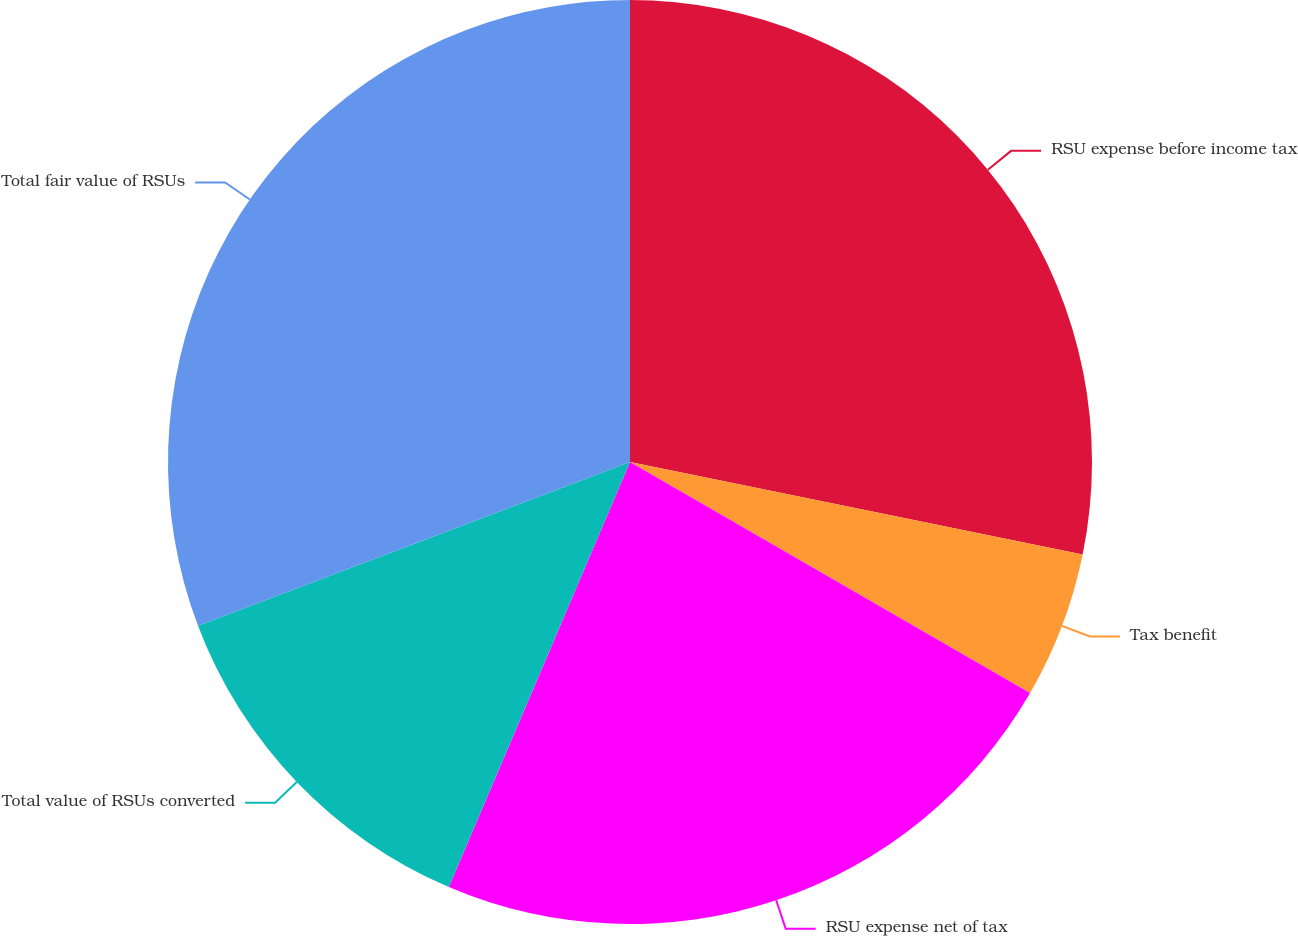Convert chart. <chart><loc_0><loc_0><loc_500><loc_500><pie_chart><fcel>RSU expense before income tax<fcel>Tax benefit<fcel>RSU expense net of tax<fcel>Total value of RSUs converted<fcel>Total fair value of RSUs<nl><fcel>28.21%<fcel>5.13%<fcel>23.08%<fcel>12.82%<fcel>30.77%<nl></chart> 